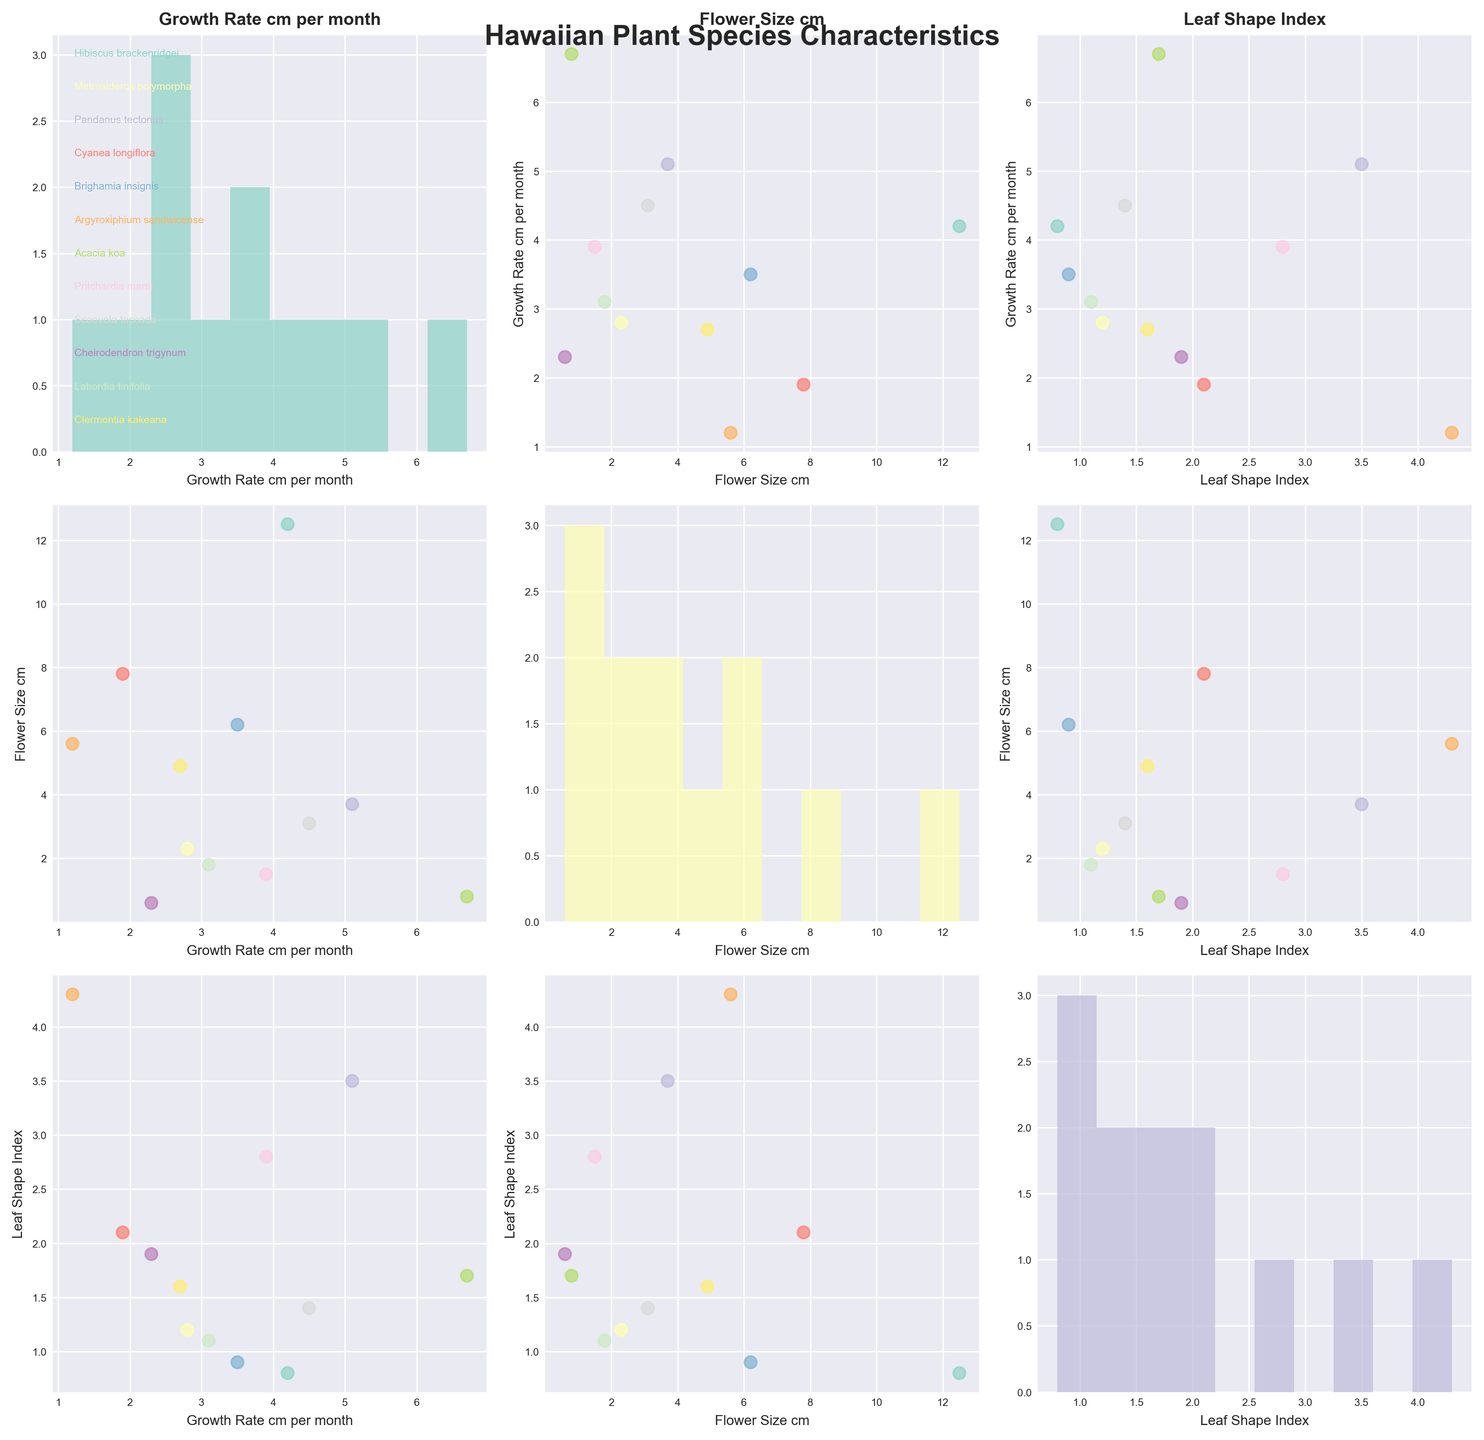How many species are visualized in the scatterplot matrix? The scatterplot matrix visualizes the species names annotated in the top-left histogram plot. All species listed are Hibiscus brackenridgei, Metrosideros polymorpha, Pandanus tectorius, Cyanea longiflora, Brighamia insignis, Argyroxiphium sandwicense, Acacia koa, Pritchardia martii, Scaevola taccada, Cheirodendron trigynum, Labordia tinifolia, and Clermontia kakeana.
Answer: 12 What is the title of the figure? The title of the figure is shown prominently at the top center.
Answer: Hawaiian Plant Species Characteristics Which species shows the highest growth rate per month? In the scatterplot where Growth Rate cm per month is compared, the highest value is represented by the uppermost dot when plotting Growth Rate cm per month. Acacia koa is at the top with a growth rate of 6.7 cm per month.
Answer: Acacia koa What is the average flower size for the species shown? To find the average, sum all the flower sizes and divide by the number of species. The sum is 12.5 + 2.3 + 3.7 + 7.8 + 6.2 + 5.6 + 0.8 + 1.5 + 3.1 + 0.6 + 1.8 + 4.9 = 50.8. The average is 50.8 / 12.
Answer: 4.23 cm Among the species, which one has the smallest leaf shape index? In the scatterplot matrix, find the smallest dot in the histograms or scatterplots for Leaf Shape Index. The smallest value here is 0.8.
Answer: Hibiscus brackenridgei Does higher growth rate generally relate to larger flower sizes? By observing the scatterplot matrix comparing Growth Rate cm per month and Flower Size cm, see if there is a trend where higher growth rates correspond to larger flower sizes. There doesn't seem to be a clear, consistent relationship.
Answer: No Which species has a combination of the highest growth rate and the largest flower size? Look for the scatterplot where Growth Rate cm per month and Flower Size cm intersect. Identify the species positions at the intersection of the highest values of both axes. There isn't a species with both highest growth rate and the largest flower size; however, Acacia koa has the highest with 6.7 cm/month but a very small flower, while Hibiscus brackenridgei has a high flower size but lower growth rate.
Answer: None (no single species has both highest values) What is the median growth rate among the species? Sort the growth rates and select the middle value. The growth rates are 1.2, 1.9, 2.3, 2.7, 2.8, 3.1, 3.5, 3.9, 4.2, 4.5, 5.1, and 6.7. Median is the average of 3.1 and 3.5.
Answer: 3.3 cm per month Which two species have the most similar leaf shape index? In the scatterplot or histogram of the Leaf Shape Index, find two species whose indices are closest to each other. Labordia tinifolia and Metrosideros polymorpha have indices of 1.1 and 1.2, respectively.
Answer: Labordia tinifolia and Metrosideros polymorpha 